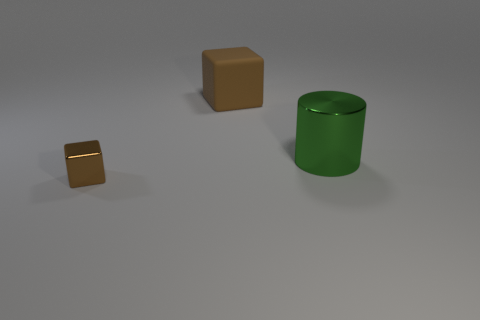There is a cube that is the same color as the small metal object; what size is it?
Provide a succinct answer. Large. Do the big cylinder and the thing that is behind the big green metallic thing have the same material?
Your answer should be compact. No. How many objects are brown cubes that are on the left side of the big brown thing or big things?
Provide a succinct answer. 3. There is a object that is in front of the large brown cube and on the left side of the big green metallic thing; what shape is it?
Your response must be concise. Cube. Is there any other thing that has the same size as the green thing?
Your response must be concise. Yes. There is a thing that is made of the same material as the big green cylinder; what size is it?
Offer a terse response. Small. How many things are either blocks that are behind the large green shiny object or brown cubes behind the small block?
Your answer should be very brief. 1. Does the object that is to the right of the matte thing have the same size as the tiny brown block?
Provide a succinct answer. No. What color is the block that is to the right of the metallic block?
Your response must be concise. Brown. What color is the other object that is the same shape as the large brown matte object?
Make the answer very short. Brown. 